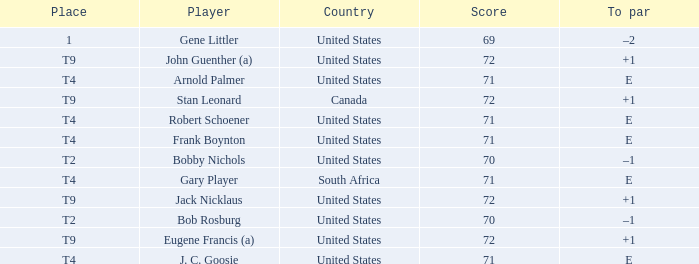What is To Par, when Country is "United States", when Place is "T4", and when Player is "Arnold Palmer"? E. 